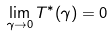<formula> <loc_0><loc_0><loc_500><loc_500>\lim _ { \gamma \rightarrow 0 } T ^ { * } ( \gamma ) = 0</formula> 